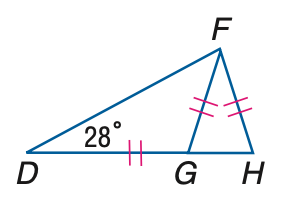Question: \triangle D F G and \triangle F G H are isosceles, m \angle F D H = 28 and D G \cong F G \cong F H. Find the measure of \angle D F G.
Choices:
A. 22
B. 24
C. 26
D. 28
Answer with the letter. Answer: D Question: \triangle D F G and \triangle F G H are isosceles, m \angle F D H = 28 and D G \cong F G \cong F H. Find the measure of \angle G F H.
Choices:
A. 62
B. 64
C. 66
D. 68
Answer with the letter. Answer: D 